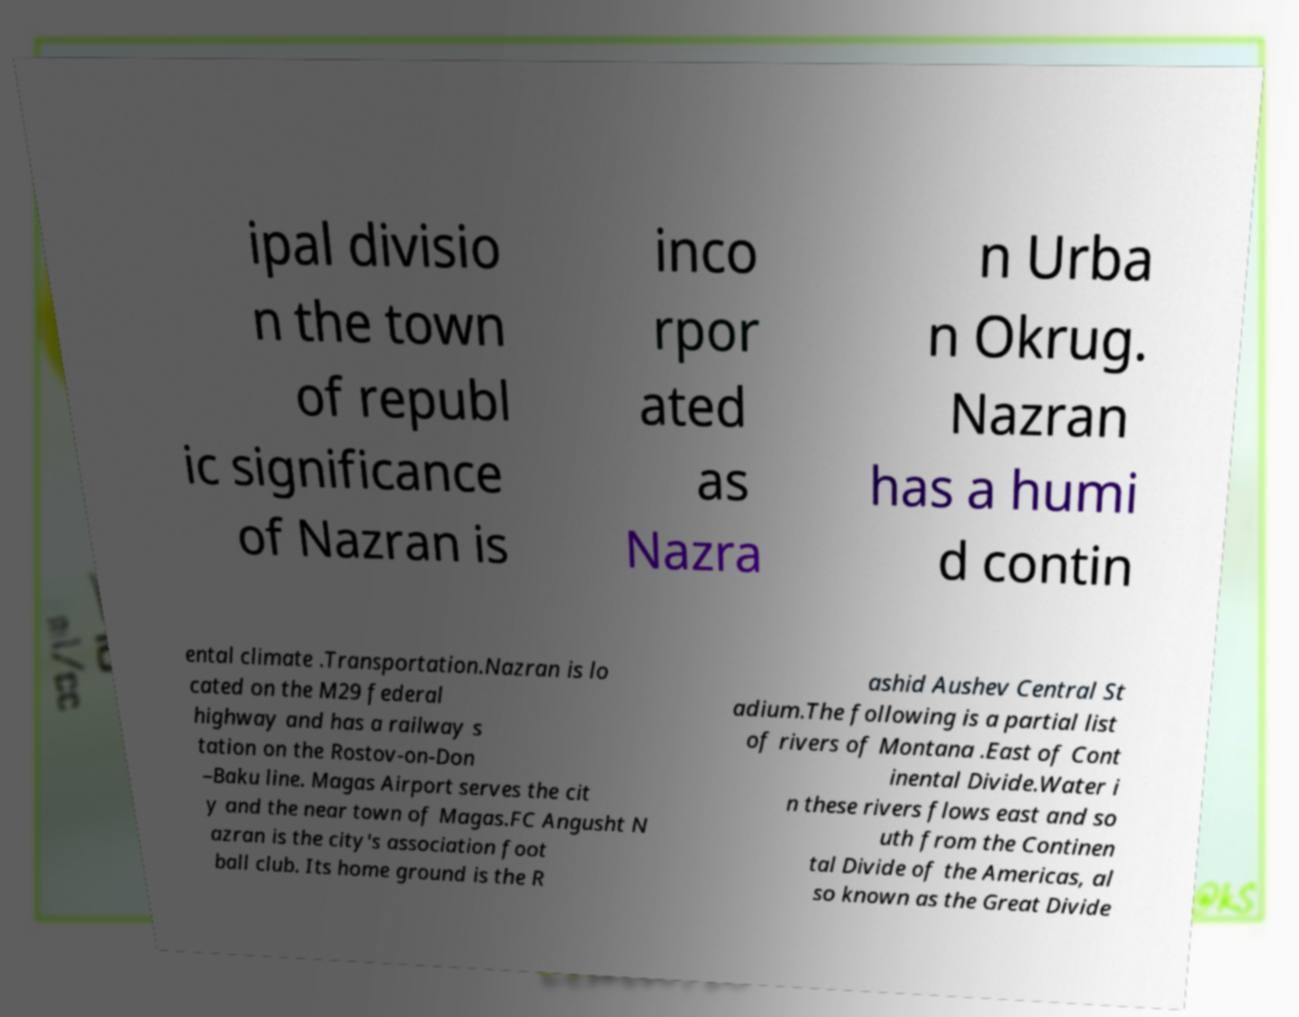Please identify and transcribe the text found in this image. ipal divisio n the town of republ ic significance of Nazran is inco rpor ated as Nazra n Urba n Okrug. Nazran has a humi d contin ental climate .Transportation.Nazran is lo cated on the M29 federal highway and has a railway s tation on the Rostov-on-Don –Baku line. Magas Airport serves the cit y and the near town of Magas.FC Angusht N azran is the city's association foot ball club. Its home ground is the R ashid Aushev Central St adium.The following is a partial list of rivers of Montana .East of Cont inental Divide.Water i n these rivers flows east and so uth from the Continen tal Divide of the Americas, al so known as the Great Divide 